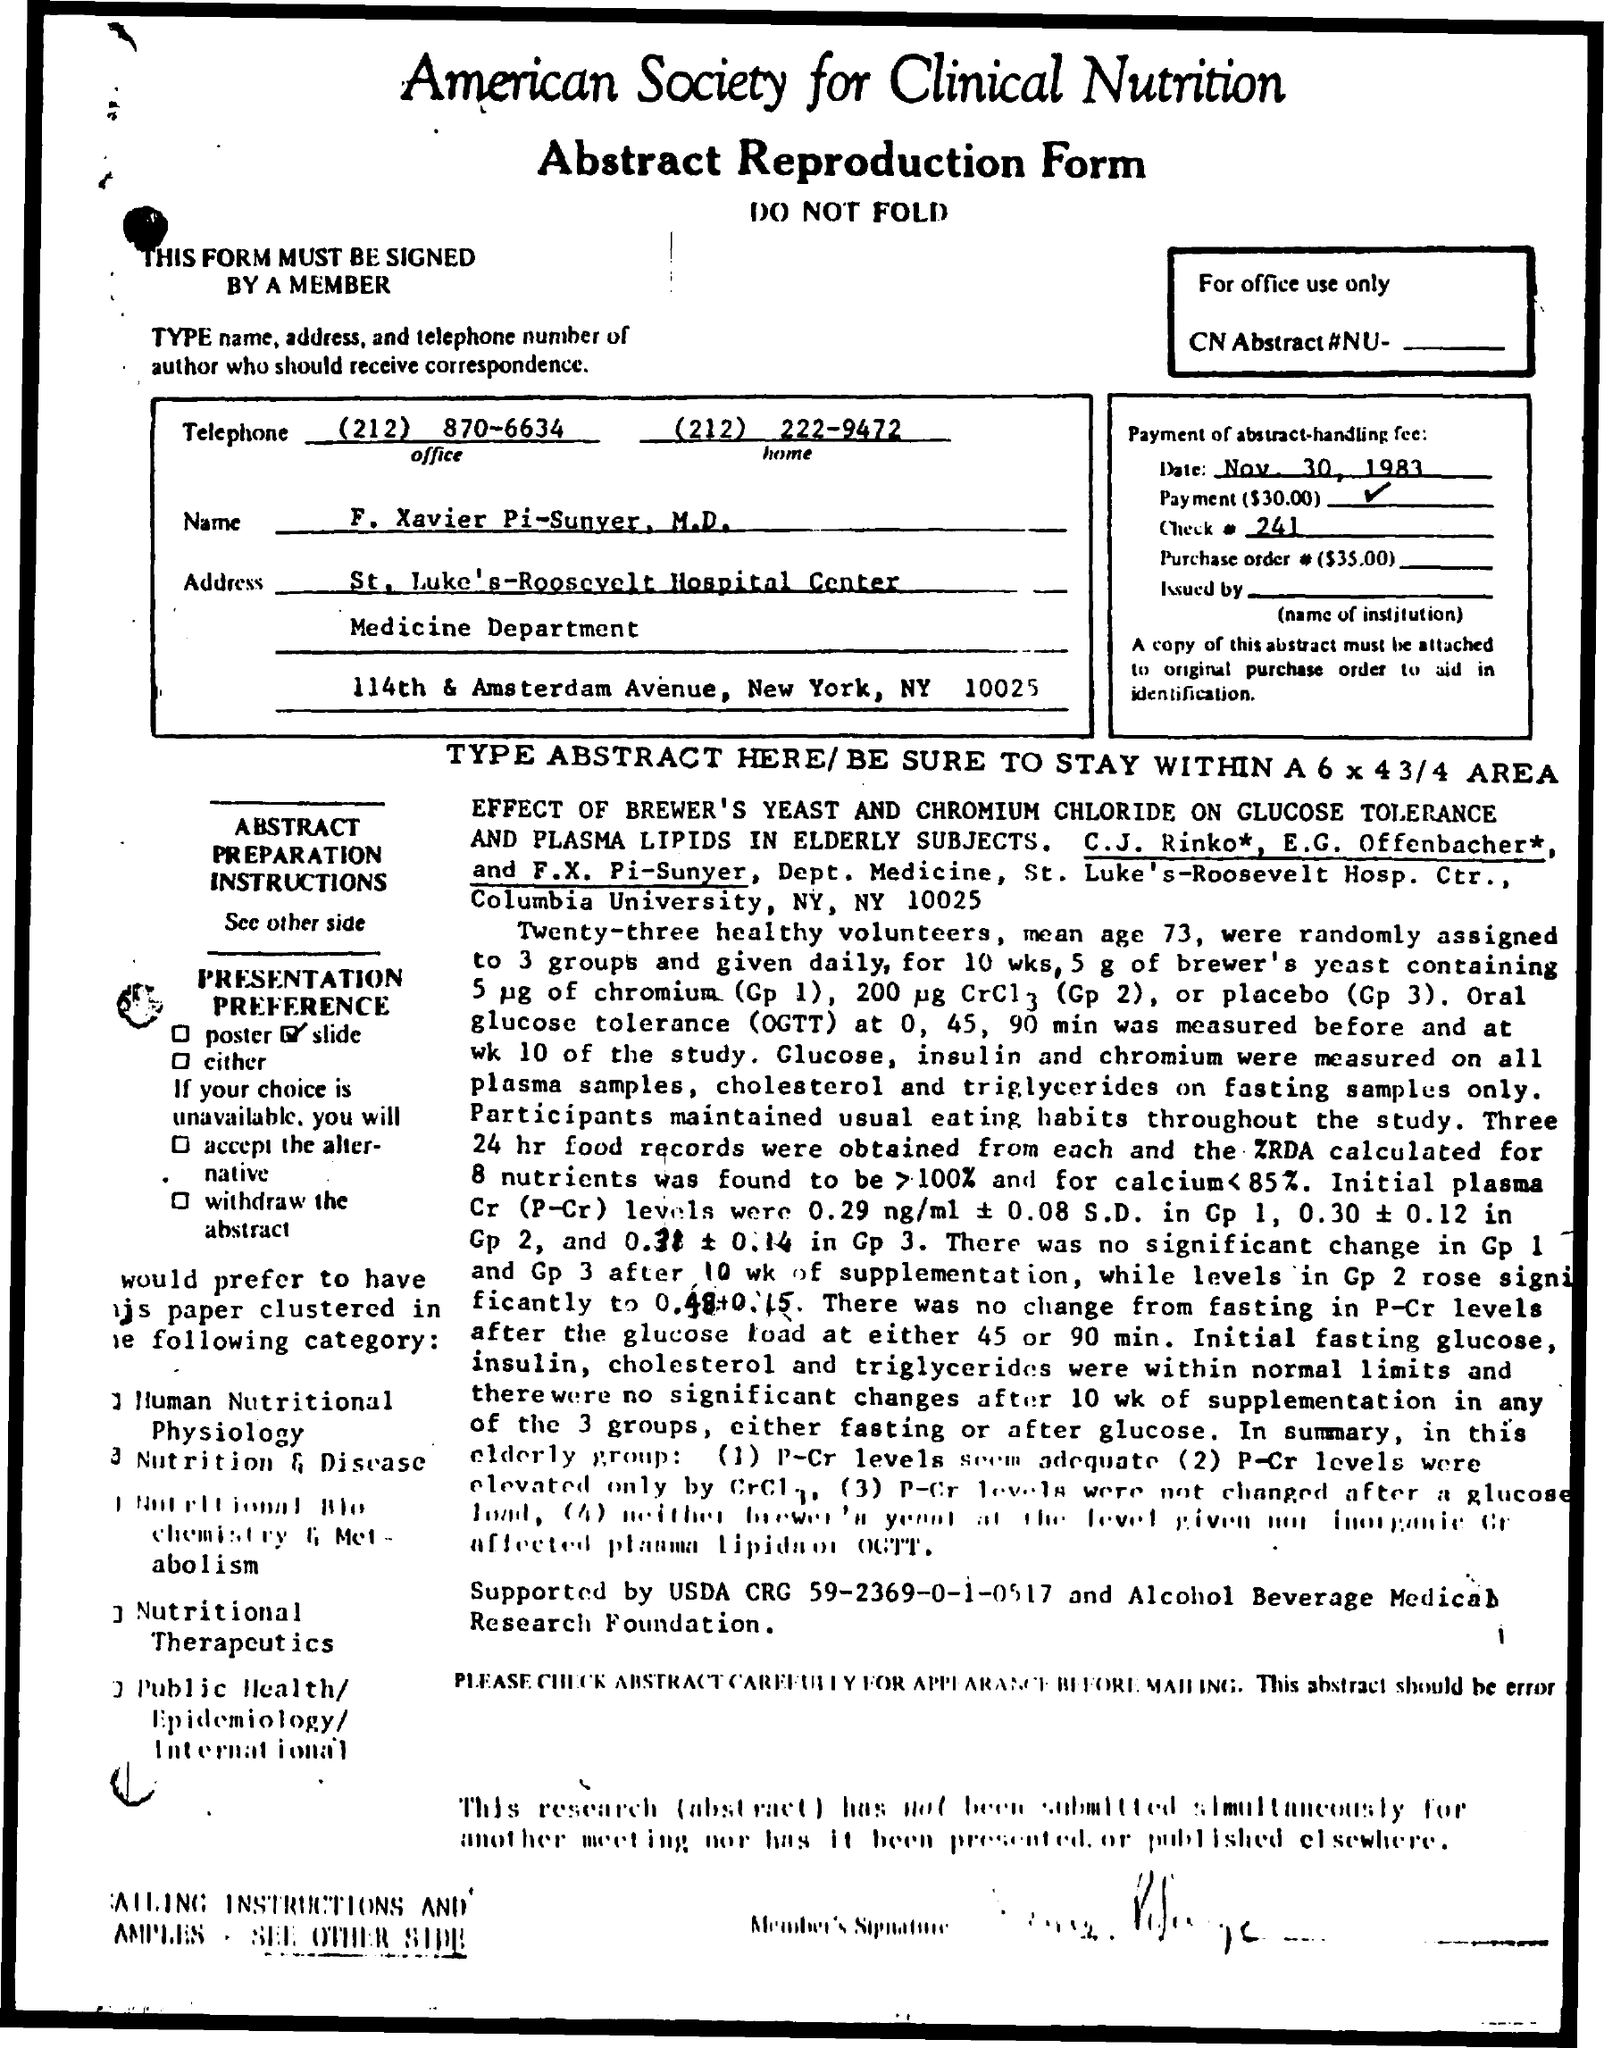Highlight a few significant elements in this photo. The home telephone number The office telephone number mentioned is (212) 870-6634. The check number is 241... On November 30th, 1983, the date mentioned, was a specific date. The city mentioned in the address is New York. 